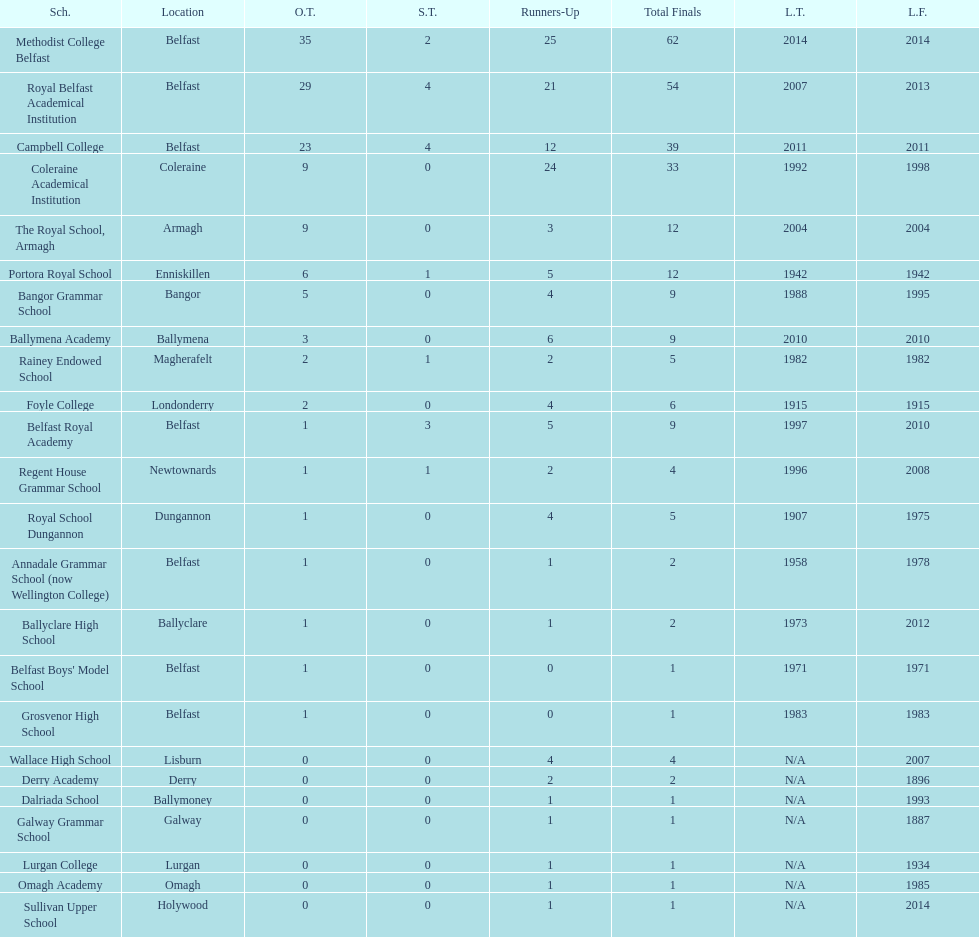How many schools have at least 5 outright titles? 7. 